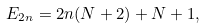Convert formula to latex. <formula><loc_0><loc_0><loc_500><loc_500>E _ { 2 n } = 2 n ( N + 2 ) + N + 1 ,</formula> 